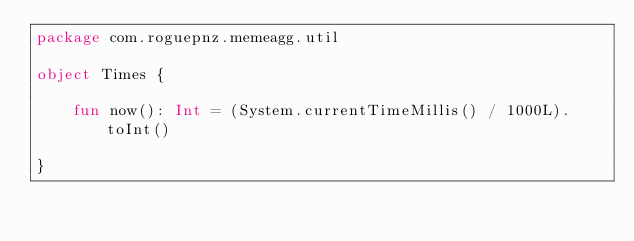<code> <loc_0><loc_0><loc_500><loc_500><_Kotlin_>package com.roguepnz.memeagg.util

object Times {

    fun now(): Int = (System.currentTimeMillis() / 1000L).toInt()

}</code> 